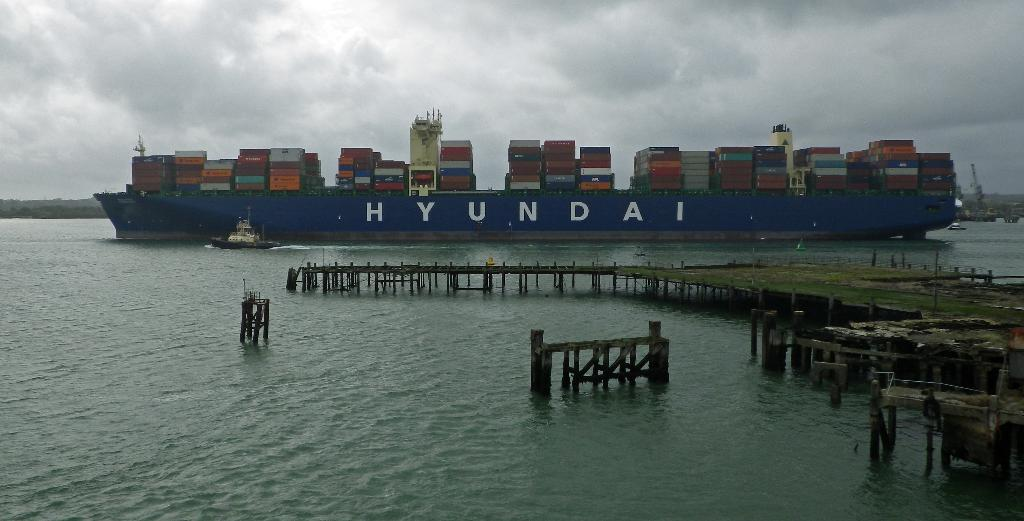What type of structures can be seen in the image? There are fences in the image. What is the elevated structure in the image? There is a platform in the image. What type of watercraft can be seen in the image? There is a boat and a ship in the image. Where are the boat and ship located in the image? The boat and ship are on water in the image. What can be seen in the background of the image? There are objects and the sky visible in the background of the image. What is the condition of the sky in the image? Clouds are present in the sky in the image. How many trucks can be seen driving through space in the image? There are no trucks or space present in the image; it features fences, a platform, a boat, a ship, and water. What type of key is used to unlock the ship in the image? There is no key present in the image, and the ship is not locked. 